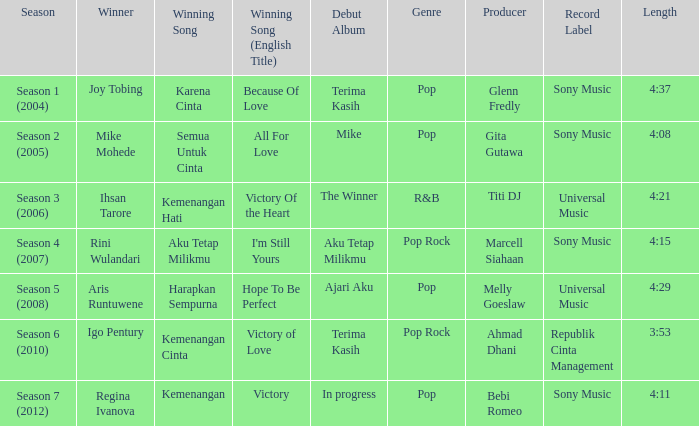Which winning song was sung by aku tetap milikmu? I'm Still Yours. Parse the table in full. {'header': ['Season', 'Winner', 'Winning Song', 'Winning Song (English Title)', 'Debut Album', 'Genre', 'Producer', 'Record Label', 'Length'], 'rows': [['Season 1 (2004)', 'Joy Tobing', 'Karena Cinta', 'Because Of Love', 'Terima Kasih', 'Pop', 'Glenn Fredly', 'Sony Music', '4:37'], ['Season 2 (2005)', 'Mike Mohede', 'Semua Untuk Cinta', 'All For Love', 'Mike', 'Pop', 'Gita Gutawa', 'Sony Music', '4:08'], ['Season 3 (2006)', 'Ihsan Tarore', 'Kemenangan Hati', 'Victory Of the Heart', 'The Winner', 'R&B', 'Titi DJ', 'Universal Music', '4:21'], ['Season 4 (2007)', 'Rini Wulandari', 'Aku Tetap Milikmu', "I'm Still Yours", 'Aku Tetap Milikmu', 'Pop Rock', 'Marcell Siahaan', 'Sony Music', '4:15'], ['Season 5 (2008)', 'Aris Runtuwene', 'Harapkan Sempurna', 'Hope To Be Perfect', 'Ajari Aku', 'Pop', 'Melly Goeslaw', 'Universal Music', '4:29'], ['Season 6 (2010)', 'Igo Pentury', 'Kemenangan Cinta', 'Victory of Love', 'Terima Kasih', 'Pop Rock', 'Ahmad Dhani', 'Republik Cinta Management', '3:53'], ['Season 7 (2012)', 'Regina Ivanova', 'Kemenangan', 'Victory', 'In progress', 'Pop', 'Bebi Romeo', 'Sony Music', '4:11']]} 